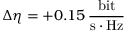Convert formula to latex. <formula><loc_0><loc_0><loc_500><loc_500>\Delta \eta = + 0 . 1 5 \, \frac { b i t } { s \cdot H z }</formula> 